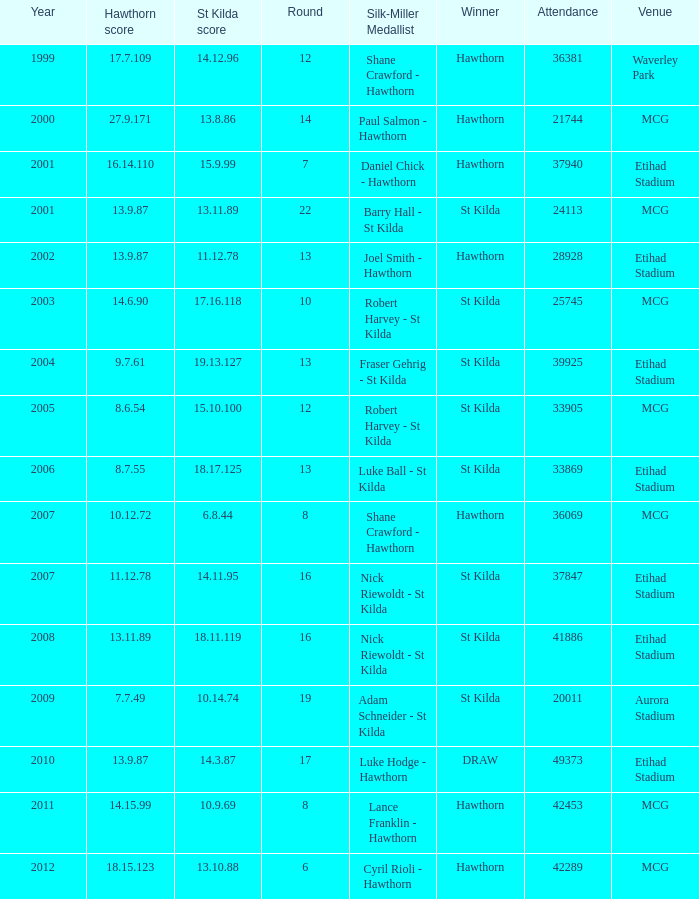What is the attendance when the st kilda score is 13.10.88? 42289.0. 